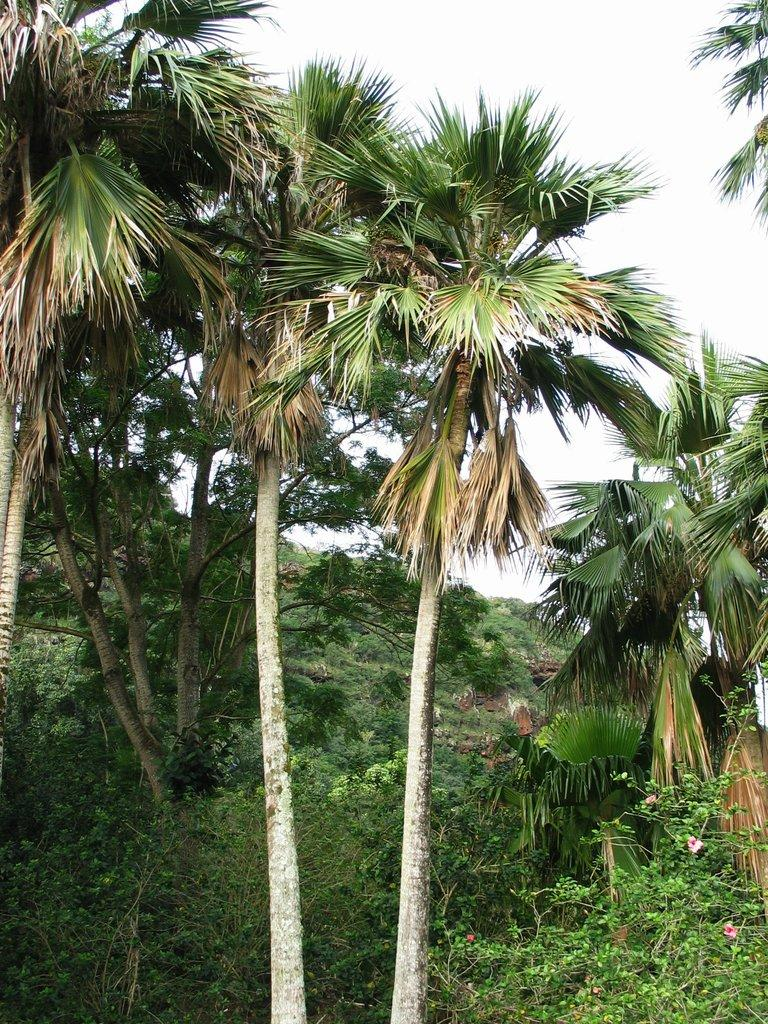What type of vegetation can be seen in the image? There are trees and flowers in the image. What can be seen in the background of the image? The sky is visible in the background of the image. What organization is responsible for maintaining the arch in the image? There is no arch present in the image, so it is not possible to determine which organization might be responsible for maintaining it. 